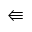Convert formula to latex. <formula><loc_0><loc_0><loc_500><loc_500>\L l e f t a r r o w</formula> 